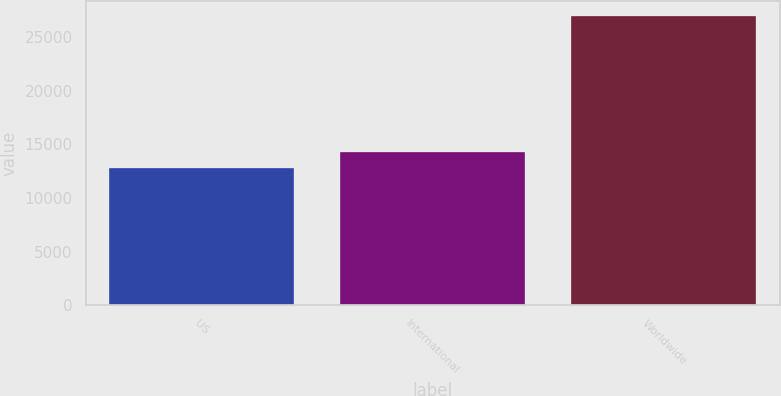Convert chart. <chart><loc_0><loc_0><loc_500><loc_500><bar_chart><fcel>US<fcel>International<fcel>Worldwide<nl><fcel>12837<fcel>14252.7<fcel>26994<nl></chart> 